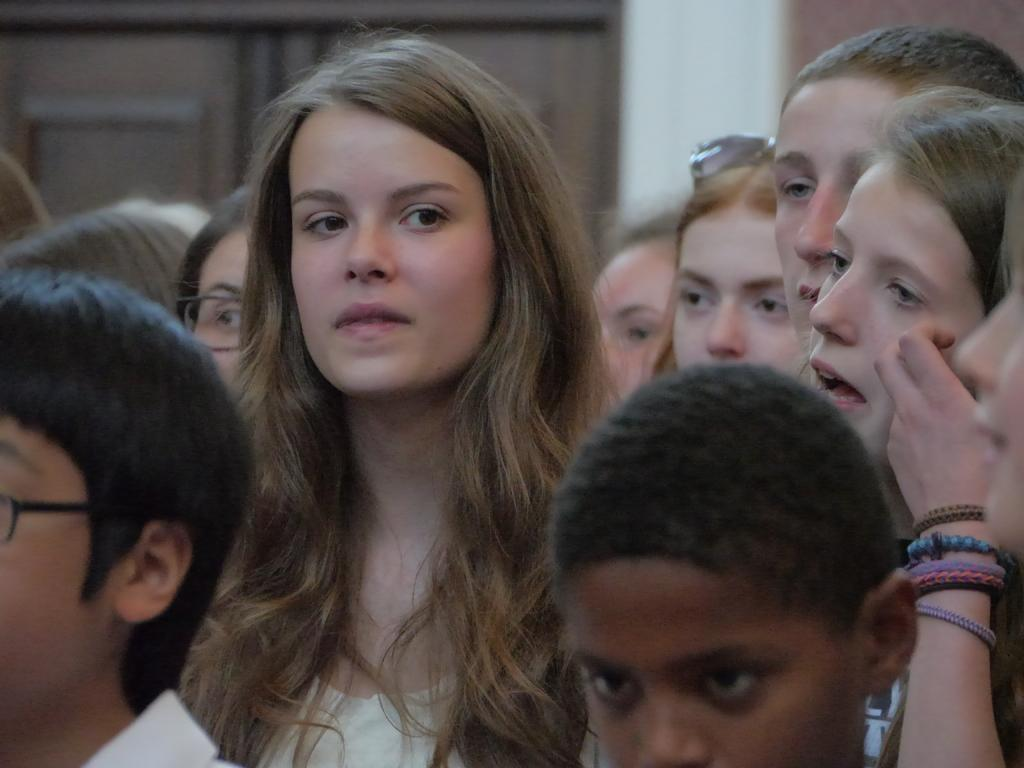What is the main subject of the image? The main subject of the image is children. What is the birth weight of the children in the image? There is no information about the birth weight of the children in the image. 